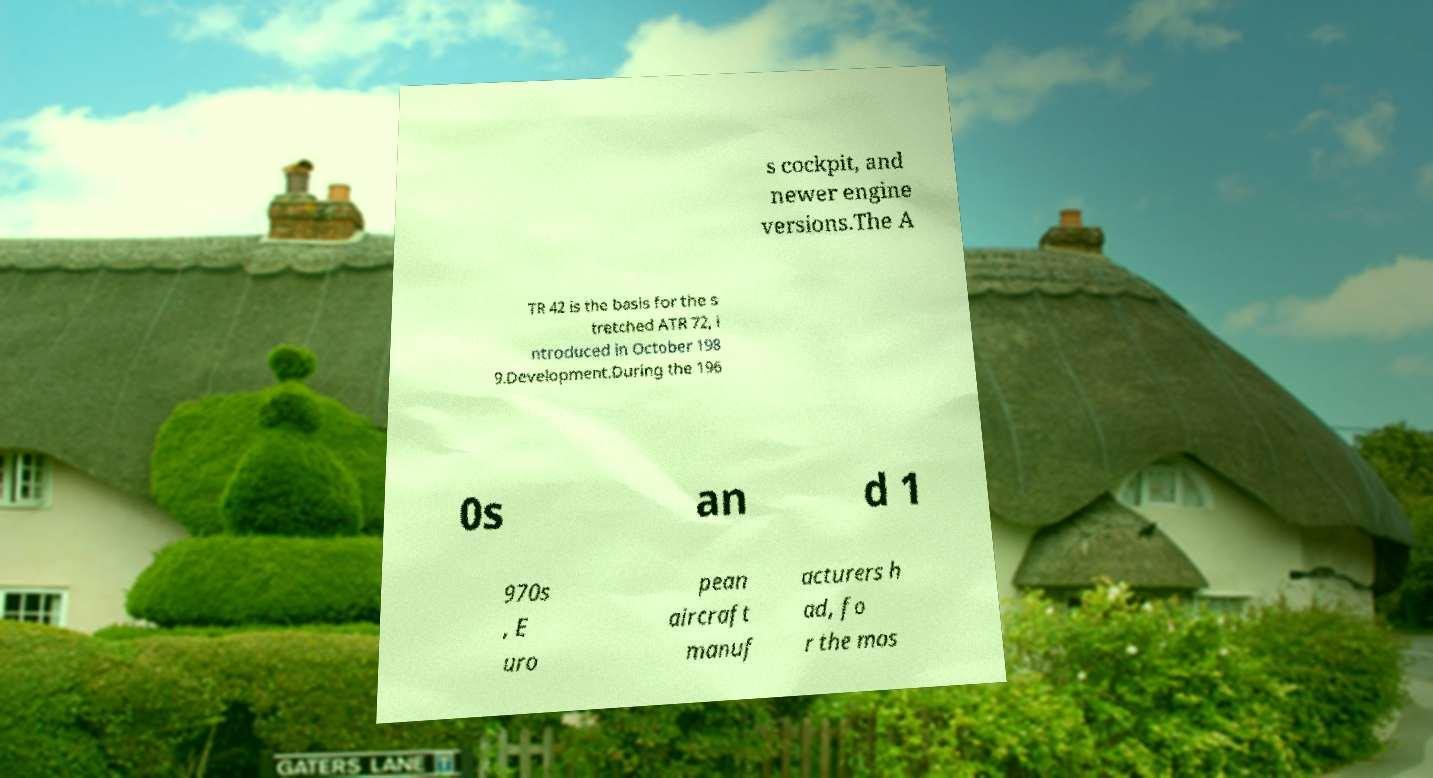There's text embedded in this image that I need extracted. Can you transcribe it verbatim? s cockpit, and newer engine versions.The A TR 42 is the basis for the s tretched ATR 72, i ntroduced in October 198 9.Development.During the 196 0s an d 1 970s , E uro pean aircraft manuf acturers h ad, fo r the mos 